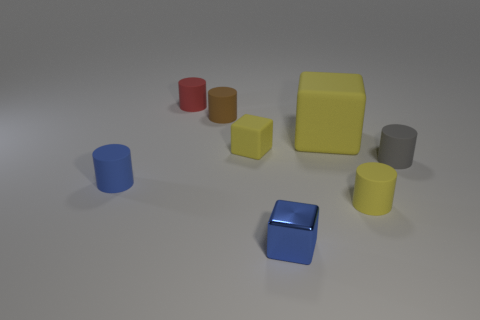There is a yellow cube that is right of the blue cube; what is its size?
Your response must be concise. Large. Is the material of the tiny blue cylinder the same as the large cube?
Your answer should be very brief. Yes. What is the shape of the tiny gray thing that is made of the same material as the tiny brown object?
Your answer should be compact. Cylinder. The small block in front of the gray rubber thing is what color?
Your answer should be very brief. Blue. Does the cylinder that is on the left side of the red cylinder have the same color as the small shiny object?
Ensure brevity in your answer.  Yes. What material is the blue object that is the same shape as the big yellow matte object?
Your answer should be compact. Metal. What number of metal cubes have the same size as the red object?
Keep it short and to the point. 1. There is a metal thing; what shape is it?
Your answer should be compact. Cube. There is a object that is in front of the tiny blue cylinder and to the left of the yellow cylinder; what size is it?
Make the answer very short. Small. There is a thing behind the brown rubber thing; what is its material?
Offer a terse response. Rubber. 